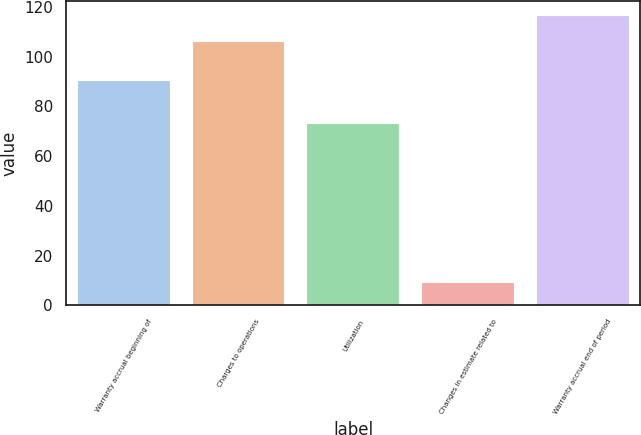Convert chart. <chart><loc_0><loc_0><loc_500><loc_500><bar_chart><fcel>Warranty accrual beginning of<fcel>Charges to operations<fcel>Utilization<fcel>Changes in estimate related to<fcel>Warranty accrual end of period<nl><fcel>90<fcel>106<fcel>73<fcel>9<fcel>116.5<nl></chart> 